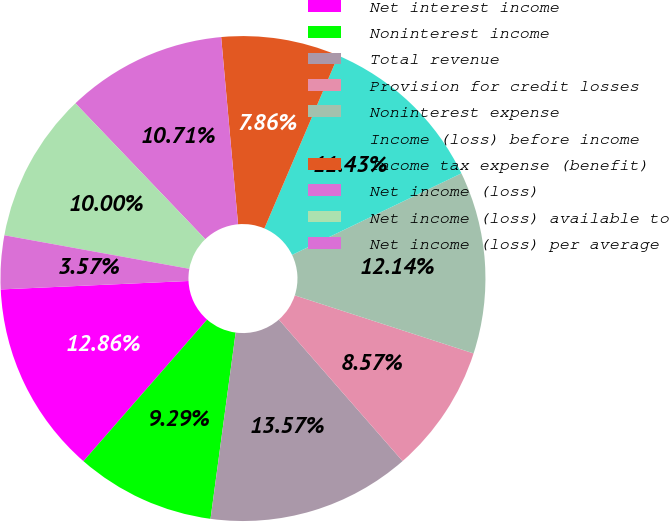Convert chart to OTSL. <chart><loc_0><loc_0><loc_500><loc_500><pie_chart><fcel>Net interest income<fcel>Noninterest income<fcel>Total revenue<fcel>Provision for credit losses<fcel>Noninterest expense<fcel>Income (loss) before income<fcel>Income tax expense (benefit)<fcel>Net income (loss)<fcel>Net income (loss) available to<fcel>Net income (loss) per average<nl><fcel>12.86%<fcel>9.29%<fcel>13.57%<fcel>8.57%<fcel>12.14%<fcel>11.43%<fcel>7.86%<fcel>10.71%<fcel>10.0%<fcel>3.57%<nl></chart> 